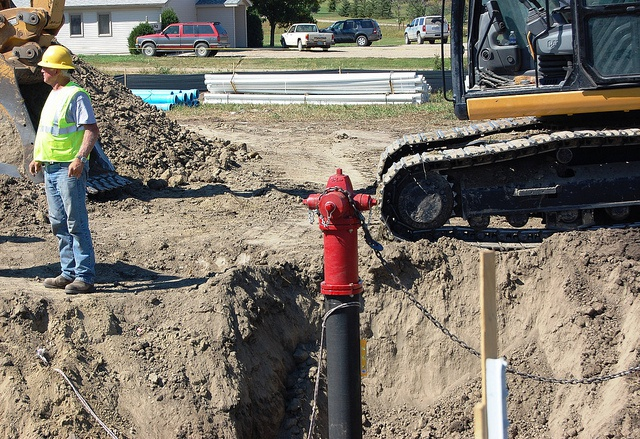Describe the objects in this image and their specific colors. I can see people in black, ivory, navy, blue, and gray tones, fire hydrant in black, gray, maroon, and salmon tones, car in black, gray, blue, and darkgray tones, truck in black, white, gray, and darkgray tones, and car in black, navy, gray, and blue tones in this image. 